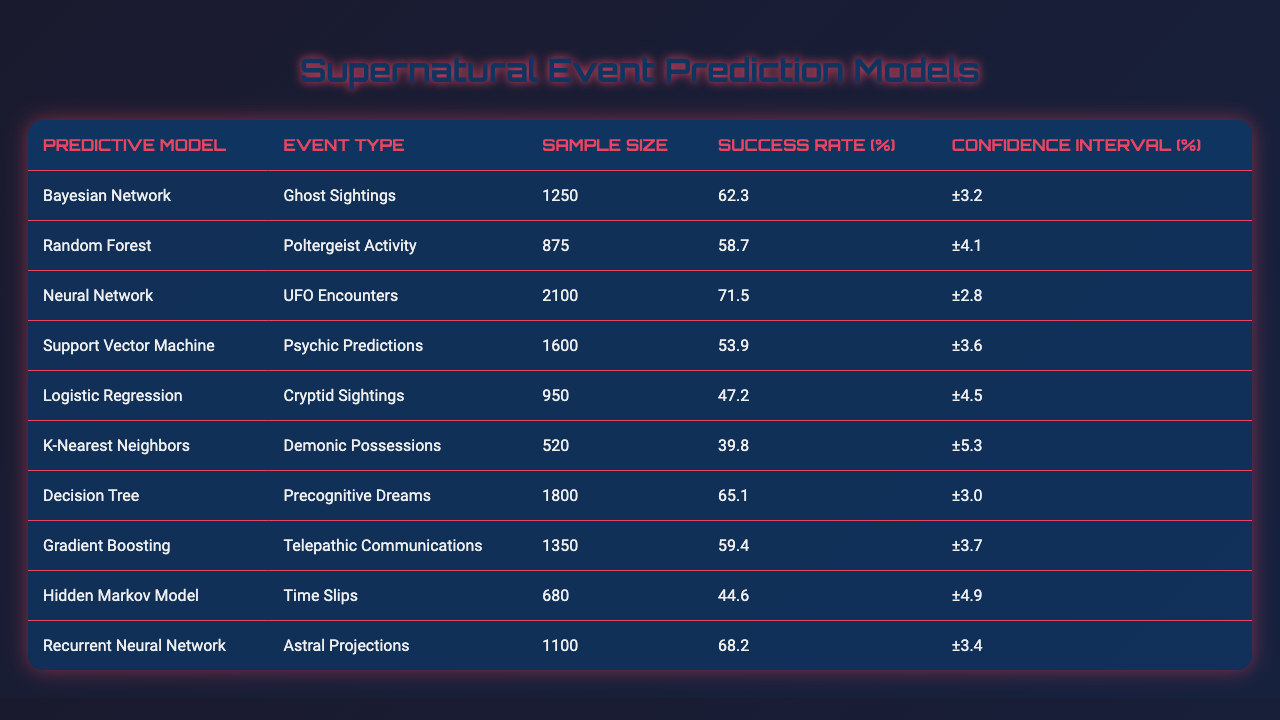What predictive model has the highest success rate for UFO encounters? The table shows that the Neural Network model has a success rate of 71.5% for UFO encounters, which is the highest among all listed models for this type of event.
Answer: Neural Network What is the success rate of the Bayesian Network model in predicting ghost sightings? According to the table, the success rate for the Bayesian Network model in predicting ghost sightings is 62.3%.
Answer: 62.3% Which model had the lowest success rate for demonic possessions and what was that rate? The K-Nearest Neighbors model had the lowest success rate at 39.8% for predicting demonic possessions, as stated in the table.
Answer: 39.8% What is the average success rate of all predictive models listed in the table? To calculate the average, we sum the success rates: (62.3 + 58.7 + 71.5 + 53.9 + 47.2 + 39.8 + 65.1 + 59.4 + 44.6 + 68.2) =  467.7. There are 10 models, so the average is 467.7 / 10 = 46.77%.
Answer: 46.77% Is the success rate for telepathic communications higher than that for psychic predictions? The success rate for telepathic communications is 59.4%, whereas psychic predictions have a success rate of 53.9%. Therefore, it is true that telepathic communications have a higher success rate.
Answer: Yes Which model has a confidence interval of ±3.0%, and what is its success rate? The Decision Tree model has a confidence interval of ±3.0%, and its success rate is 65.1% for precognitive dreams, according to the table.
Answer: 65.1% Compare the success rates of Random Forest and Gradient Boosting. Which is better? Random Forest has a success rate of 58.7%, while Gradient Boosting has a success rate of 59.4%. Since 59.4% is greater than 58.7%, Gradient Boosting is the better model for this comparison.
Answer: Gradient Boosting What is the total sample size of models predicting cryptid sightings and ghost sightings combined? The sample size for cryptid sightings via Logistic Regression is 950 and for ghost sightings via Bayesian Network is 1250. Adding these gives us a total sample size of 950 + 1250 = 2200.
Answer: 2200 Is there a predictive model that demonstrates a success rate equal to or above 70%? Yes, the Neural Network model shows a success rate of 71.5%, which is above 70%.
Answer: Yes How much lower is the success rate of Hidden Markov Model compared to the Neural Network? The success rate of the Hidden Markov Model is 44.6%, while the Neural Network's success rate is 71.5%. The difference is found by subtracting: 71.5 - 44.6 = 26.9%, indicating the Hidden Markov Model's success rate is 26.9% lower.
Answer: 26.9% 